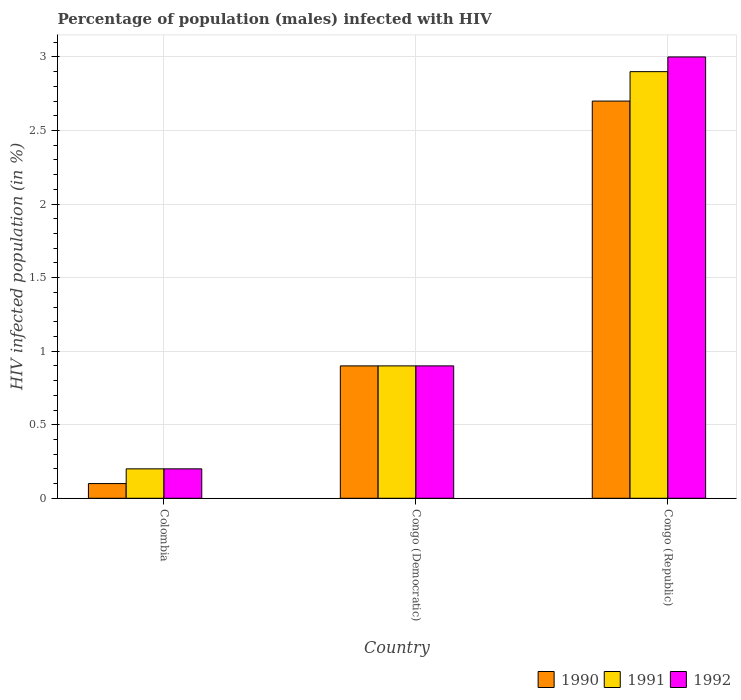How many different coloured bars are there?
Make the answer very short. 3. How many bars are there on the 2nd tick from the left?
Make the answer very short. 3. How many bars are there on the 2nd tick from the right?
Your response must be concise. 3. What is the label of the 3rd group of bars from the left?
Provide a succinct answer. Congo (Republic). In how many cases, is the number of bars for a given country not equal to the number of legend labels?
Make the answer very short. 0. In which country was the percentage of HIV infected male population in 1992 maximum?
Your response must be concise. Congo (Republic). In which country was the percentage of HIV infected male population in 1992 minimum?
Your answer should be very brief. Colombia. What is the total percentage of HIV infected male population in 1992 in the graph?
Provide a short and direct response. 4.1. What is the difference between the percentage of HIV infected male population in 1991 in Colombia and that in Congo (Republic)?
Your answer should be very brief. -2.7. What is the average percentage of HIV infected male population in 1990 per country?
Provide a succinct answer. 1.23. What is the difference between the percentage of HIV infected male population of/in 1991 and percentage of HIV infected male population of/in 1990 in Congo (Republic)?
Ensure brevity in your answer.  0.2. In how many countries, is the percentage of HIV infected male population in 1991 greater than 0.1 %?
Offer a terse response. 3. What is the ratio of the percentage of HIV infected male population in 1991 in Congo (Democratic) to that in Congo (Republic)?
Offer a very short reply. 0.31. Is the difference between the percentage of HIV infected male population in 1991 in Colombia and Congo (Democratic) greater than the difference between the percentage of HIV infected male population in 1990 in Colombia and Congo (Democratic)?
Offer a terse response. Yes. In how many countries, is the percentage of HIV infected male population in 1992 greater than the average percentage of HIV infected male population in 1992 taken over all countries?
Make the answer very short. 1. Is the sum of the percentage of HIV infected male population in 1992 in Congo (Democratic) and Congo (Republic) greater than the maximum percentage of HIV infected male population in 1990 across all countries?
Your answer should be compact. Yes. What does the 2nd bar from the left in Congo (Democratic) represents?
Ensure brevity in your answer.  1991. What does the 1st bar from the right in Colombia represents?
Your answer should be very brief. 1992. Is it the case that in every country, the sum of the percentage of HIV infected male population in 1990 and percentage of HIV infected male population in 1991 is greater than the percentage of HIV infected male population in 1992?
Provide a succinct answer. Yes. How many bars are there?
Keep it short and to the point. 9. How many countries are there in the graph?
Provide a short and direct response. 3. Where does the legend appear in the graph?
Offer a very short reply. Bottom right. What is the title of the graph?
Provide a succinct answer. Percentage of population (males) infected with HIV. Does "1971" appear as one of the legend labels in the graph?
Your answer should be compact. No. What is the label or title of the X-axis?
Your answer should be compact. Country. What is the label or title of the Y-axis?
Keep it short and to the point. HIV infected population (in %). What is the HIV infected population (in %) in 1990 in Colombia?
Offer a very short reply. 0.1. What is the HIV infected population (in %) in 1991 in Colombia?
Your answer should be very brief. 0.2. What is the HIV infected population (in %) in 1992 in Colombia?
Offer a very short reply. 0.2. What is the HIV infected population (in %) in 1992 in Congo (Democratic)?
Your answer should be very brief. 0.9. What is the HIV infected population (in %) of 1990 in Congo (Republic)?
Provide a succinct answer. 2.7. What is the HIV infected population (in %) of 1991 in Congo (Republic)?
Your response must be concise. 2.9. Across all countries, what is the maximum HIV infected population (in %) in 1991?
Ensure brevity in your answer.  2.9. Across all countries, what is the minimum HIV infected population (in %) of 1990?
Your response must be concise. 0.1. Across all countries, what is the minimum HIV infected population (in %) of 1991?
Your answer should be very brief. 0.2. What is the difference between the HIV infected population (in %) of 1990 in Colombia and that in Congo (Democratic)?
Keep it short and to the point. -0.8. What is the difference between the HIV infected population (in %) in 1991 in Colombia and that in Congo (Democratic)?
Keep it short and to the point. -0.7. What is the difference between the HIV infected population (in %) of 1992 in Colombia and that in Congo (Democratic)?
Ensure brevity in your answer.  -0.7. What is the difference between the HIV infected population (in %) of 1992 in Colombia and that in Congo (Republic)?
Your answer should be compact. -2.8. What is the difference between the HIV infected population (in %) in 1991 in Congo (Democratic) and that in Congo (Republic)?
Give a very brief answer. -2. What is the difference between the HIV infected population (in %) of 1992 in Congo (Democratic) and that in Congo (Republic)?
Offer a very short reply. -2.1. What is the difference between the HIV infected population (in %) in 1991 in Colombia and the HIV infected population (in %) in 1992 in Congo (Democratic)?
Ensure brevity in your answer.  -0.7. What is the difference between the HIV infected population (in %) in 1990 in Colombia and the HIV infected population (in %) in 1991 in Congo (Republic)?
Ensure brevity in your answer.  -2.8. What is the difference between the HIV infected population (in %) in 1991 in Colombia and the HIV infected population (in %) in 1992 in Congo (Republic)?
Give a very brief answer. -2.8. What is the difference between the HIV infected population (in %) of 1990 in Congo (Democratic) and the HIV infected population (in %) of 1991 in Congo (Republic)?
Offer a terse response. -2. What is the difference between the HIV infected population (in %) of 1991 in Congo (Democratic) and the HIV infected population (in %) of 1992 in Congo (Republic)?
Make the answer very short. -2.1. What is the average HIV infected population (in %) in 1990 per country?
Provide a succinct answer. 1.23. What is the average HIV infected population (in %) of 1991 per country?
Provide a short and direct response. 1.33. What is the average HIV infected population (in %) of 1992 per country?
Keep it short and to the point. 1.37. What is the difference between the HIV infected population (in %) of 1990 and HIV infected population (in %) of 1991 in Colombia?
Your answer should be very brief. -0.1. What is the difference between the HIV infected population (in %) of 1991 and HIV infected population (in %) of 1992 in Colombia?
Ensure brevity in your answer.  0. What is the difference between the HIV infected population (in %) of 1990 and HIV infected population (in %) of 1991 in Congo (Democratic)?
Your answer should be compact. 0. What is the difference between the HIV infected population (in %) of 1990 and HIV infected population (in %) of 1991 in Congo (Republic)?
Provide a succinct answer. -0.2. What is the difference between the HIV infected population (in %) in 1990 and HIV infected population (in %) in 1992 in Congo (Republic)?
Offer a terse response. -0.3. What is the difference between the HIV infected population (in %) of 1991 and HIV infected population (in %) of 1992 in Congo (Republic)?
Your response must be concise. -0.1. What is the ratio of the HIV infected population (in %) in 1991 in Colombia to that in Congo (Democratic)?
Your answer should be very brief. 0.22. What is the ratio of the HIV infected population (in %) of 1992 in Colombia to that in Congo (Democratic)?
Keep it short and to the point. 0.22. What is the ratio of the HIV infected population (in %) in 1990 in Colombia to that in Congo (Republic)?
Provide a succinct answer. 0.04. What is the ratio of the HIV infected population (in %) of 1991 in Colombia to that in Congo (Republic)?
Ensure brevity in your answer.  0.07. What is the ratio of the HIV infected population (in %) of 1992 in Colombia to that in Congo (Republic)?
Offer a very short reply. 0.07. What is the ratio of the HIV infected population (in %) in 1991 in Congo (Democratic) to that in Congo (Republic)?
Make the answer very short. 0.31. What is the ratio of the HIV infected population (in %) in 1992 in Congo (Democratic) to that in Congo (Republic)?
Offer a very short reply. 0.3. What is the difference between the highest and the lowest HIV infected population (in %) of 1990?
Your response must be concise. 2.6. What is the difference between the highest and the lowest HIV infected population (in %) in 1992?
Offer a very short reply. 2.8. 